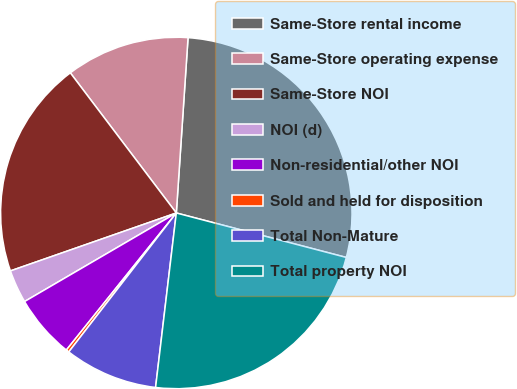Convert chart. <chart><loc_0><loc_0><loc_500><loc_500><pie_chart><fcel>Same-Store rental income<fcel>Same-Store operating expense<fcel>Same-Store NOI<fcel>NOI (d)<fcel>Non-residential/other NOI<fcel>Sold and held for disposition<fcel>Total Non-Mature<fcel>Total property NOI<nl><fcel>28.01%<fcel>11.37%<fcel>20.04%<fcel>3.06%<fcel>5.83%<fcel>0.28%<fcel>8.6%<fcel>22.81%<nl></chart> 